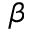Convert formula to latex. <formula><loc_0><loc_0><loc_500><loc_500>\beta</formula> 